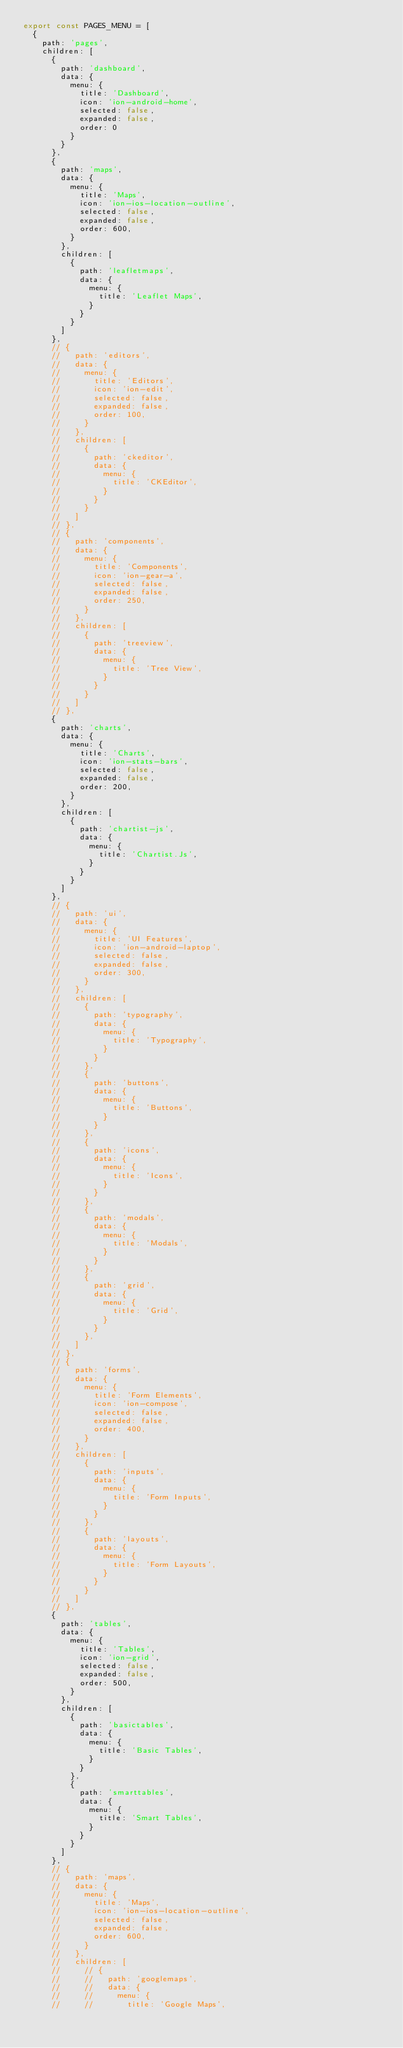<code> <loc_0><loc_0><loc_500><loc_500><_TypeScript_>export const PAGES_MENU = [
  {
    path: 'pages',
    children: [
      {
        path: 'dashboard',
        data: {
          menu: {
            title: 'Dashboard',
            icon: 'ion-android-home',
            selected: false,
            expanded: false,
            order: 0
          }
        }
      },
      {
        path: 'maps',
        data: {
          menu: {
            title: 'Maps',
            icon: 'ion-ios-location-outline',
            selected: false,
            expanded: false,
            order: 600,
          }
        },
        children: [
          {
            path: 'leafletmaps',
            data: {
              menu: {
                title: 'Leaflet Maps',
              }
            }
          }
        ]
      },
      // {
      //   path: 'editors',
      //   data: {
      //     menu: {
      //       title: 'Editors',
      //       icon: 'ion-edit',
      //       selected: false,
      //       expanded: false,
      //       order: 100,
      //     }
      //   },
      //   children: [
      //     {
      //       path: 'ckeditor',
      //       data: {
      //         menu: {
      //           title: 'CKEditor',
      //         }
      //       }
      //     }
      //   ]
      // },
      // {
      //   path: 'components',
      //   data: {
      //     menu: {
      //       title: 'Components',
      //       icon: 'ion-gear-a',
      //       selected: false,
      //       expanded: false,
      //       order: 250,
      //     }
      //   },
      //   children: [
      //     {
      //       path: 'treeview',
      //       data: {
      //         menu: {
      //           title: 'Tree View',
      //         }
      //       }
      //     }
      //   ]
      // },
      {
        path: 'charts',
        data: {
          menu: {
            title: 'Charts',
            icon: 'ion-stats-bars',
            selected: false,
            expanded: false,
            order: 200,
          }
        },
        children: [
          {
            path: 'chartist-js',
            data: {
              menu: {
                title: 'Chartist.Js',
              }
            }
          }
        ]
      },
      // {
      //   path: 'ui',
      //   data: {
      //     menu: {
      //       title: 'UI Features',
      //       icon: 'ion-android-laptop',
      //       selected: false,
      //       expanded: false,
      //       order: 300,
      //     }
      //   },
      //   children: [
      //     {
      //       path: 'typography',
      //       data: {
      //         menu: {
      //           title: 'Typography',
      //         }
      //       }
      //     },
      //     {
      //       path: 'buttons',
      //       data: {
      //         menu: {
      //           title: 'Buttons',
      //         }
      //       }
      //     },
      //     {
      //       path: 'icons',
      //       data: {
      //         menu: {
      //           title: 'Icons',
      //         }
      //       }
      //     },
      //     {
      //       path: 'modals',
      //       data: {
      //         menu: {
      //           title: 'Modals',
      //         }
      //       }
      //     },
      //     {
      //       path: 'grid',
      //       data: {
      //         menu: {
      //           title: 'Grid',
      //         }
      //       }
      //     },
      //   ]
      // },
      // {
      //   path: 'forms',
      //   data: {
      //     menu: {
      //       title: 'Form Elements',
      //       icon: 'ion-compose',
      //       selected: false,
      //       expanded: false,
      //       order: 400,
      //     }
      //   },
      //   children: [
      //     {
      //       path: 'inputs',
      //       data: {
      //         menu: {
      //           title: 'Form Inputs',
      //         }
      //       }
      //     },
      //     {
      //       path: 'layouts',
      //       data: {
      //         menu: {
      //           title: 'Form Layouts',
      //         }
      //       }
      //     }
      //   ]
      // },
      {
        path: 'tables',
        data: {
          menu: {
            title: 'Tables',
            icon: 'ion-grid',
            selected: false,
            expanded: false,
            order: 500,
          }
        },
        children: [
          {
            path: 'basictables',
            data: {
              menu: {
                title: 'Basic Tables',
              }
            }
          },
          {
            path: 'smarttables',
            data: {
              menu: {
                title: 'Smart Tables',
              }
            }
          }
        ]
      },
      // {
      //   path: 'maps',
      //   data: {
      //     menu: {
      //       title: 'Maps',
      //       icon: 'ion-ios-location-outline',
      //       selected: false,
      //       expanded: false,
      //       order: 600,
      //     }
      //   },
      //   children: [
      //     // {
      //     //   path: 'googlemaps',
      //     //   data: {
      //     //     menu: {
      //     //       title: 'Google Maps',</code> 